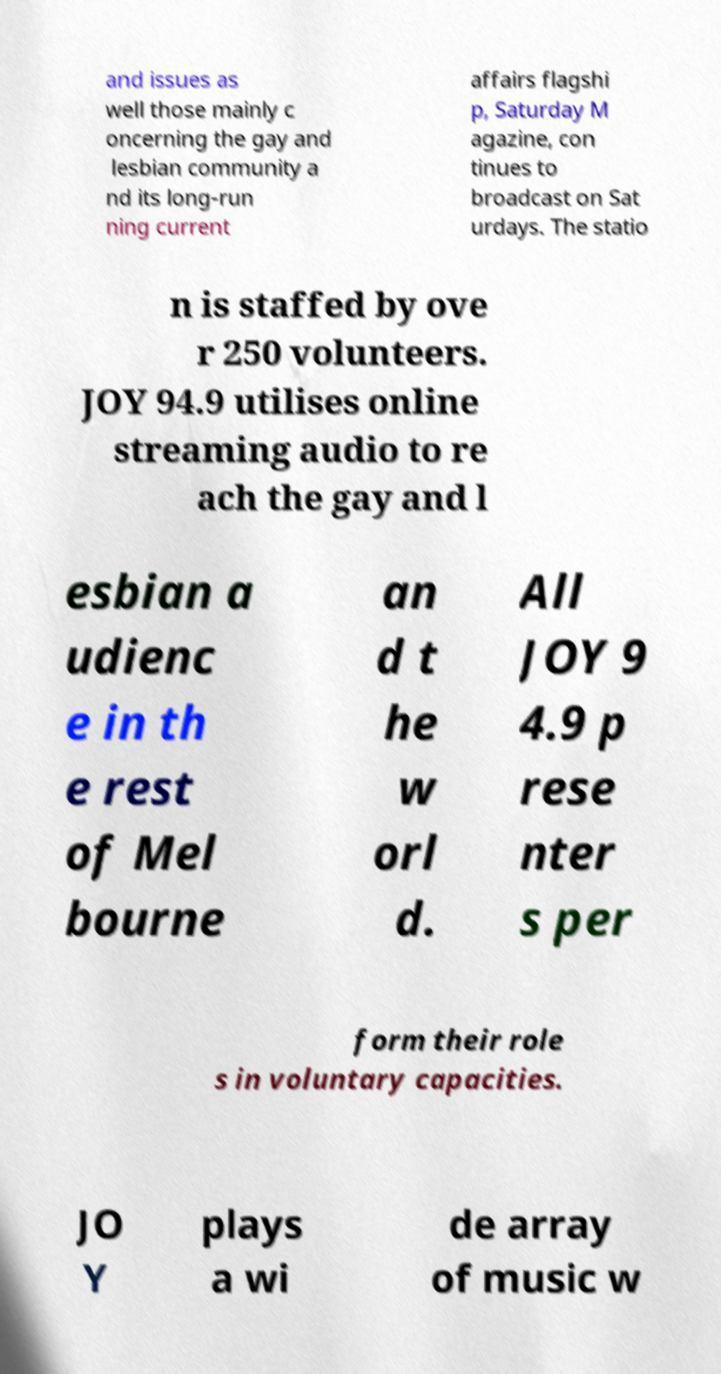There's text embedded in this image that I need extracted. Can you transcribe it verbatim? and issues as well those mainly c oncerning the gay and lesbian community a nd its long-run ning current affairs flagshi p, Saturday M agazine, con tinues to broadcast on Sat urdays. The statio n is staffed by ove r 250 volunteers. JOY 94.9 utilises online streaming audio to re ach the gay and l esbian a udienc e in th e rest of Mel bourne an d t he w orl d. All JOY 9 4.9 p rese nter s per form their role s in voluntary capacities. JO Y plays a wi de array of music w 